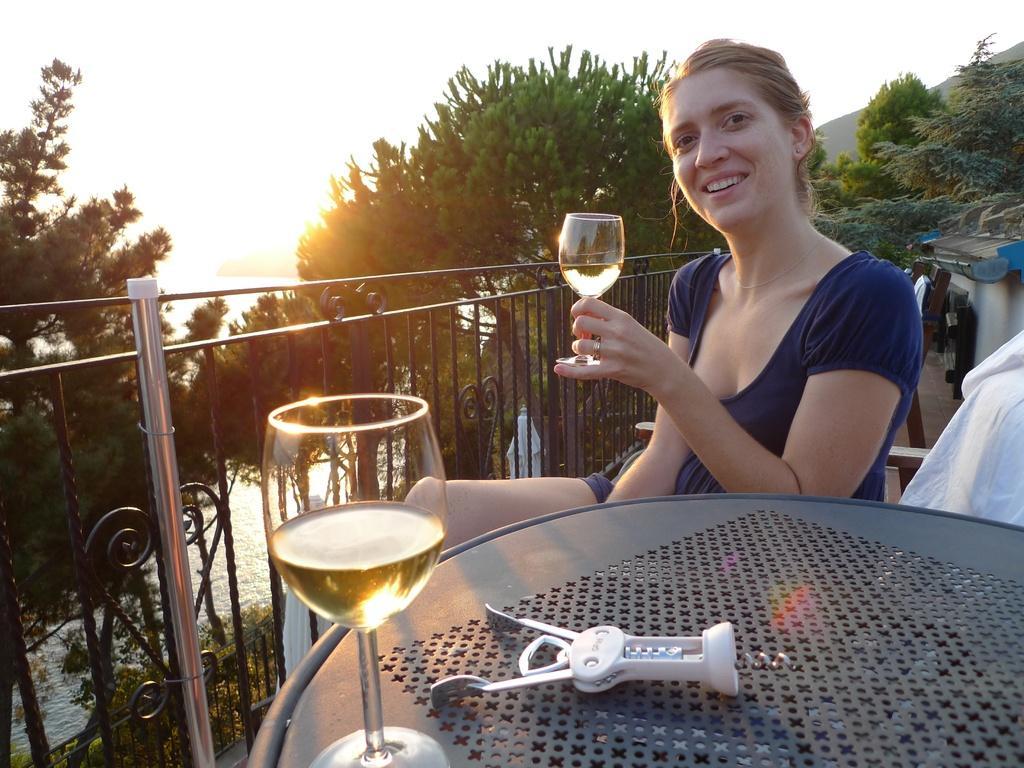In one or two sentences, can you explain what this image depicts? In this image I see a woman who is sitting and holding a glass in her hand, I can also see that she is smiling and there is a table in front of her on which there is another glass and a thing. In the background I see the fence and the trees and I can also see the water. 